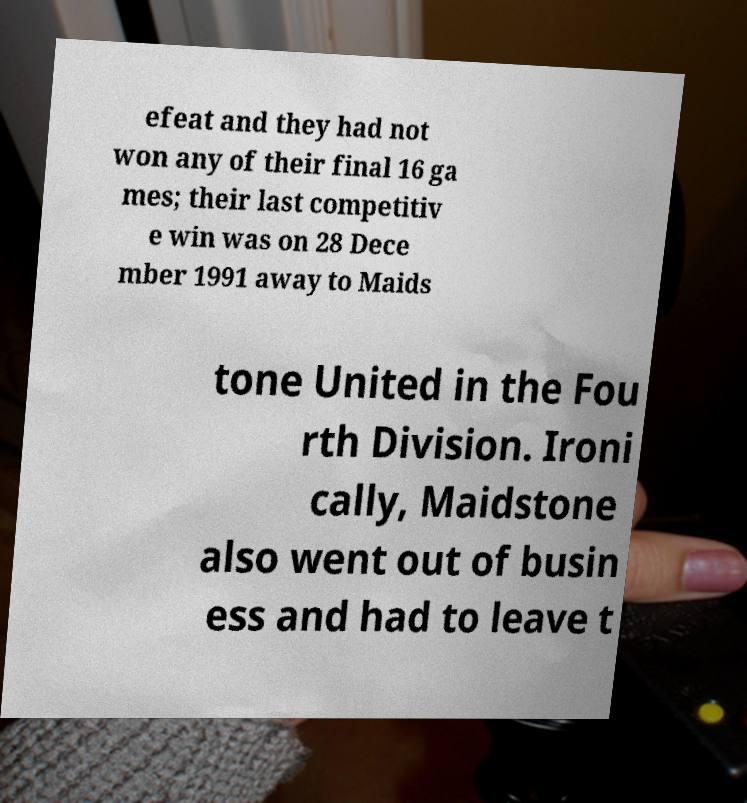For documentation purposes, I need the text within this image transcribed. Could you provide that? efeat and they had not won any of their final 16 ga mes; their last competitiv e win was on 28 Dece mber 1991 away to Maids tone United in the Fou rth Division. Ironi cally, Maidstone also went out of busin ess and had to leave t 